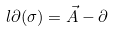<formula> <loc_0><loc_0><loc_500><loc_500>l \partial ( \sigma ) = \vec { A } - \partial</formula> 